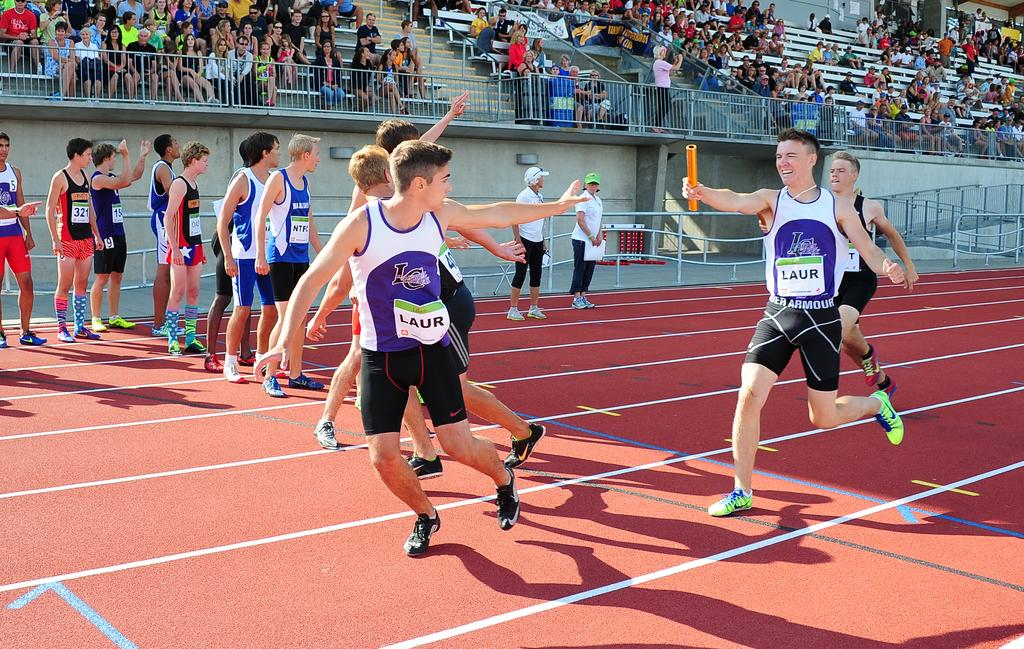<image>
Render a clear and concise summary of the photo. Runners wearing Under Armour shorts cheer each other on as the pass the batons to the next person 